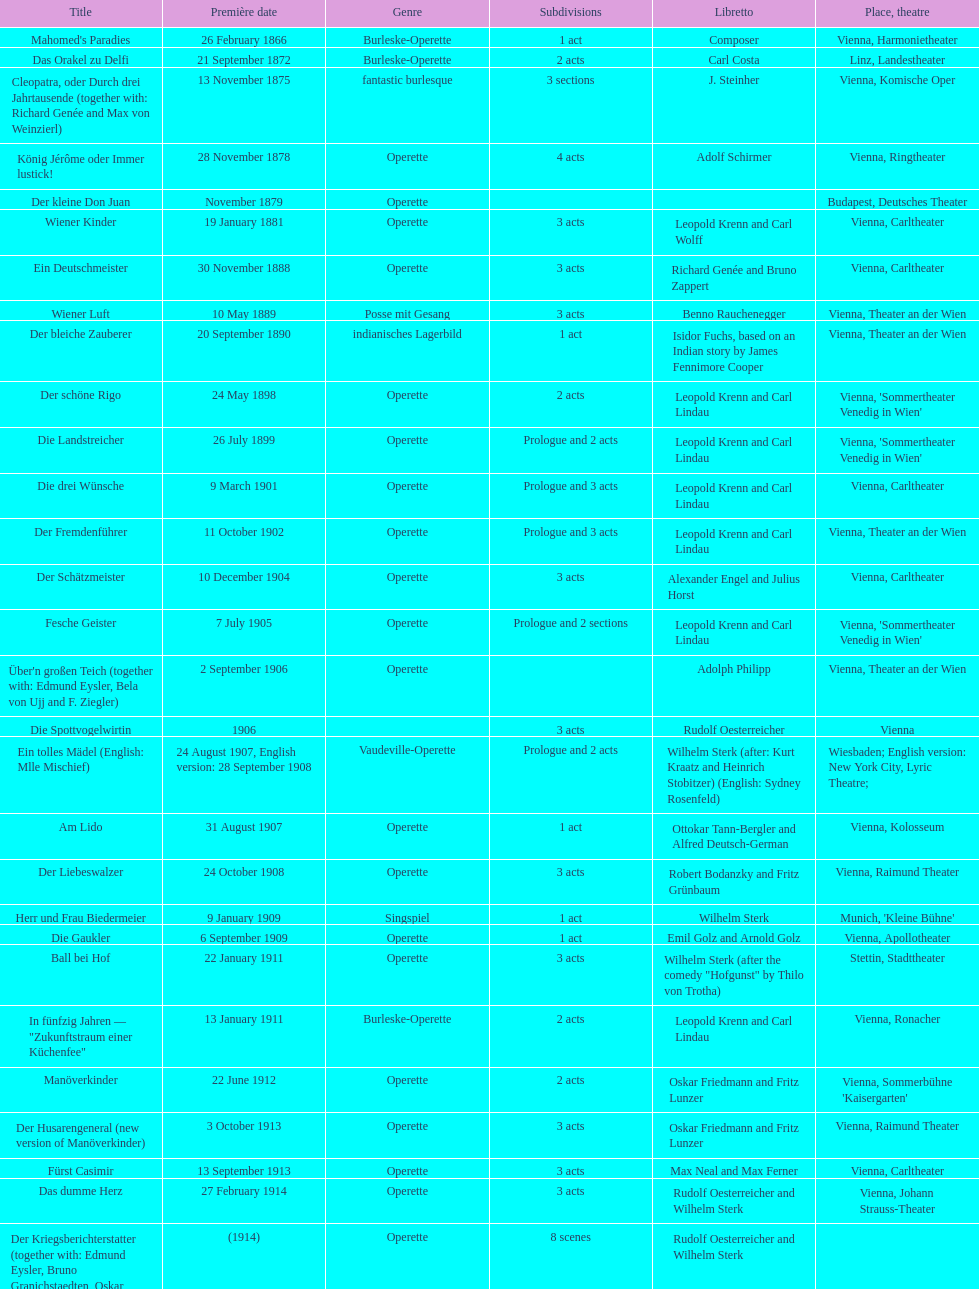Which genre is featured the most in this chart? Operette. 